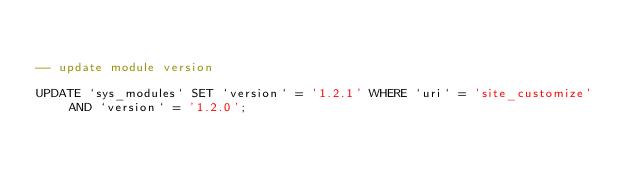Convert code to text. <code><loc_0><loc_0><loc_500><loc_500><_SQL_>

-- update module version

UPDATE `sys_modules` SET `version` = '1.2.1' WHERE `uri` = 'site_customize' AND `version` = '1.2.0';

</code> 